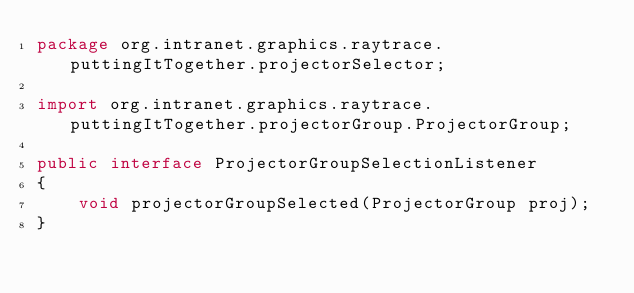Convert code to text. <code><loc_0><loc_0><loc_500><loc_500><_Java_>package org.intranet.graphics.raytrace.puttingItTogether.projectorSelector;

import org.intranet.graphics.raytrace.puttingItTogether.projectorGroup.ProjectorGroup;

public interface ProjectorGroupSelectionListener
{
	void projectorGroupSelected(ProjectorGroup proj);
}</code> 